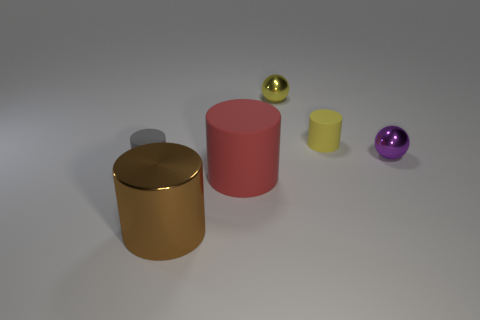Add 4 tiny yellow cylinders. How many objects exist? 10 Subtract all big metal cylinders. How many cylinders are left? 3 Subtract all gray cylinders. How many cylinders are left? 3 Subtract all cylinders. How many objects are left? 2 Add 1 red matte objects. How many red matte objects exist? 2 Subtract 0 blue spheres. How many objects are left? 6 Subtract all purple spheres. Subtract all brown cubes. How many spheres are left? 1 Subtract all small green metallic spheres. Subtract all brown cylinders. How many objects are left? 5 Add 2 small purple metal balls. How many small purple metal balls are left? 3 